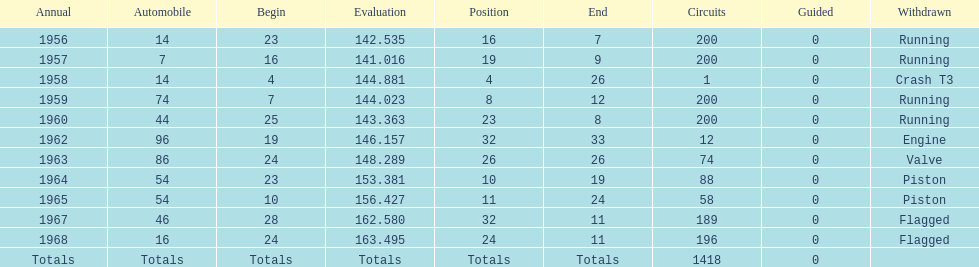What was its best starting position? 4. 